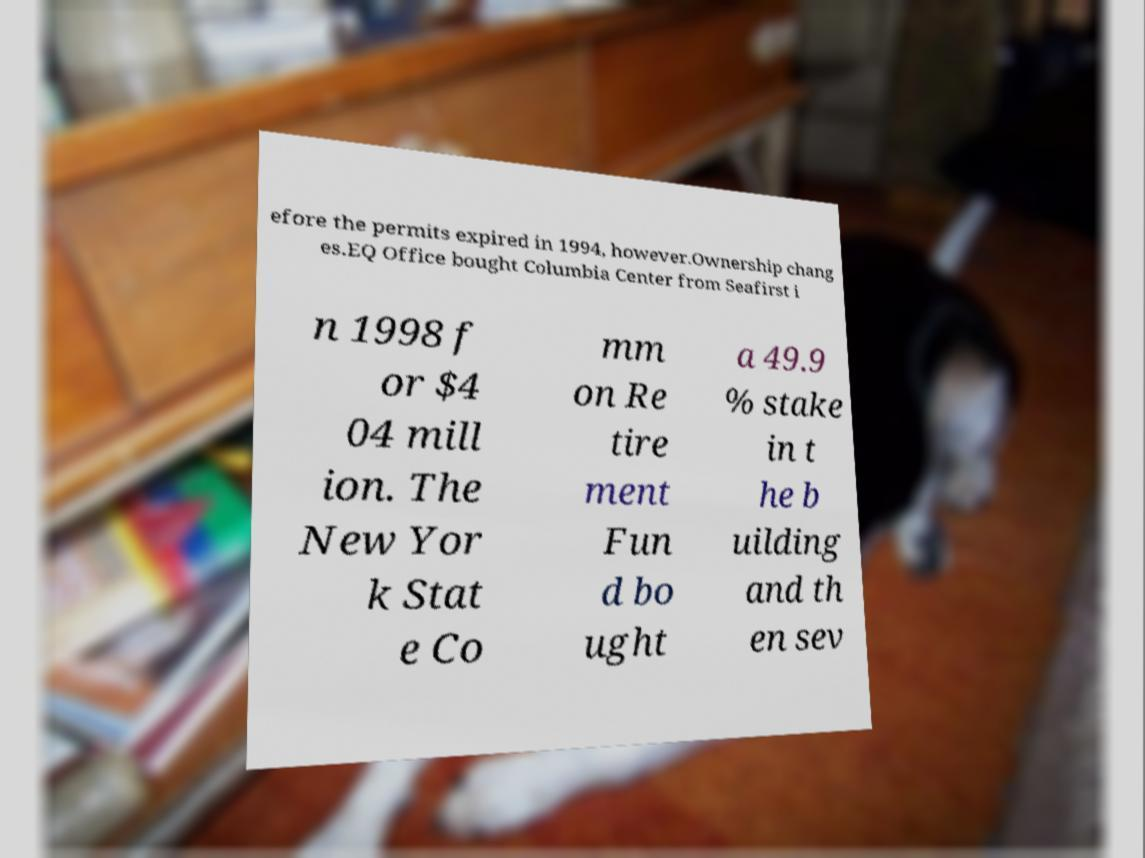Please identify and transcribe the text found in this image. efore the permits expired in 1994, however.Ownership chang es.EQ Office bought Columbia Center from Seafirst i n 1998 f or $4 04 mill ion. The New Yor k Stat e Co mm on Re tire ment Fun d bo ught a 49.9 % stake in t he b uilding and th en sev 